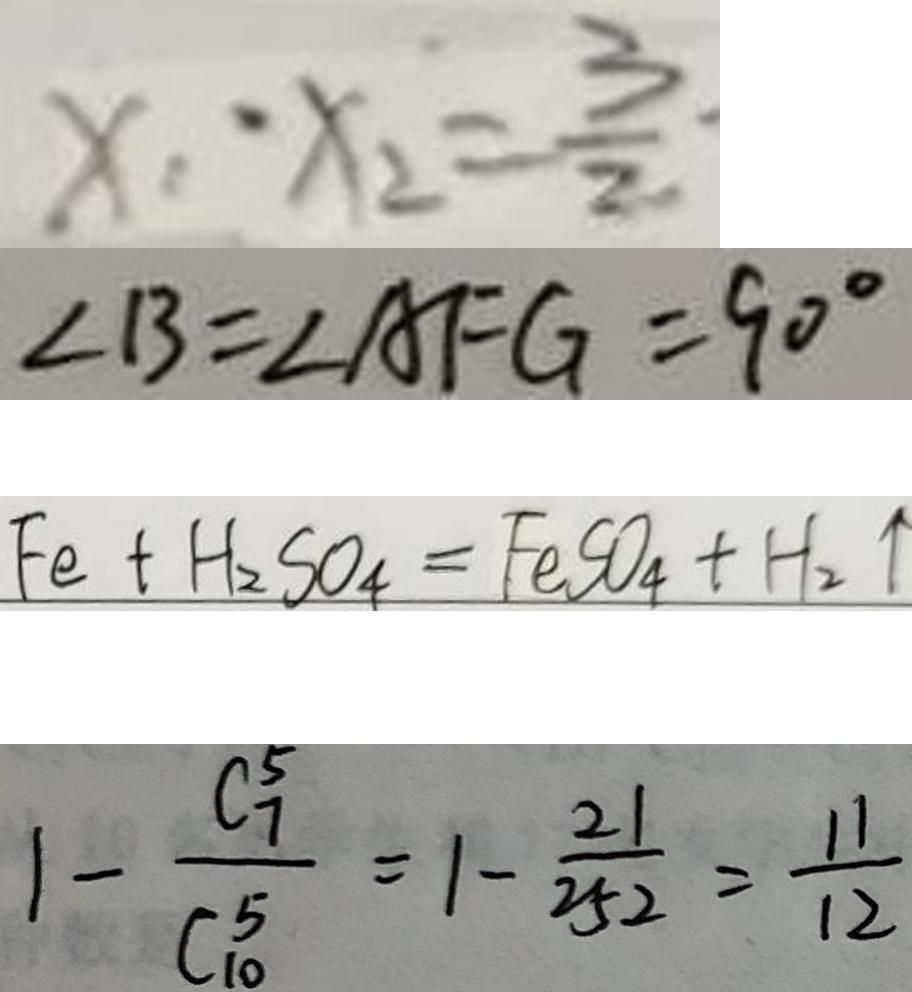Convert formula to latex. <formula><loc_0><loc_0><loc_500><loc_500>x _ { 1 } \cdot x _ { 2 } = \frac { 3 } { 2 } 
 \angle B = \angle A F G = 9 0 ^ { \circ } 
 F e + H _ { 2 } S O _ { 4 } = F e S O _ { 4 } + H _ { 2 } \uparrow 
 1 - \frac { C _ { 7 } ^ { 5 } } { C _ { 1 0 } ^ { 5 } } = 1 - \frac { 2 1 } { 2 5 2 } = \frac { 1 1 } { 1 2 }</formula> 